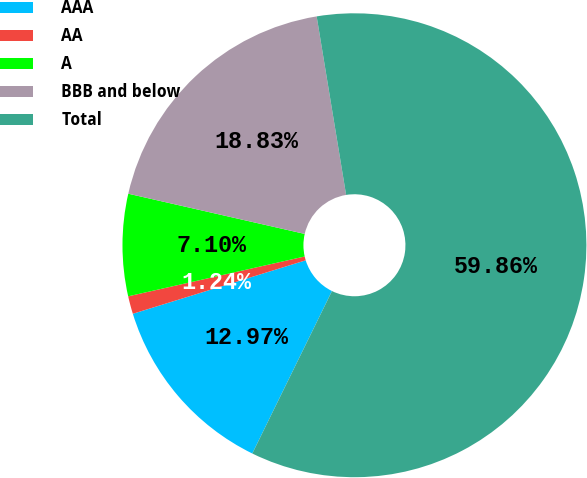<chart> <loc_0><loc_0><loc_500><loc_500><pie_chart><fcel>AAA<fcel>AA<fcel>A<fcel>BBB and below<fcel>Total<nl><fcel>12.97%<fcel>1.24%<fcel>7.1%<fcel>18.83%<fcel>59.86%<nl></chart> 